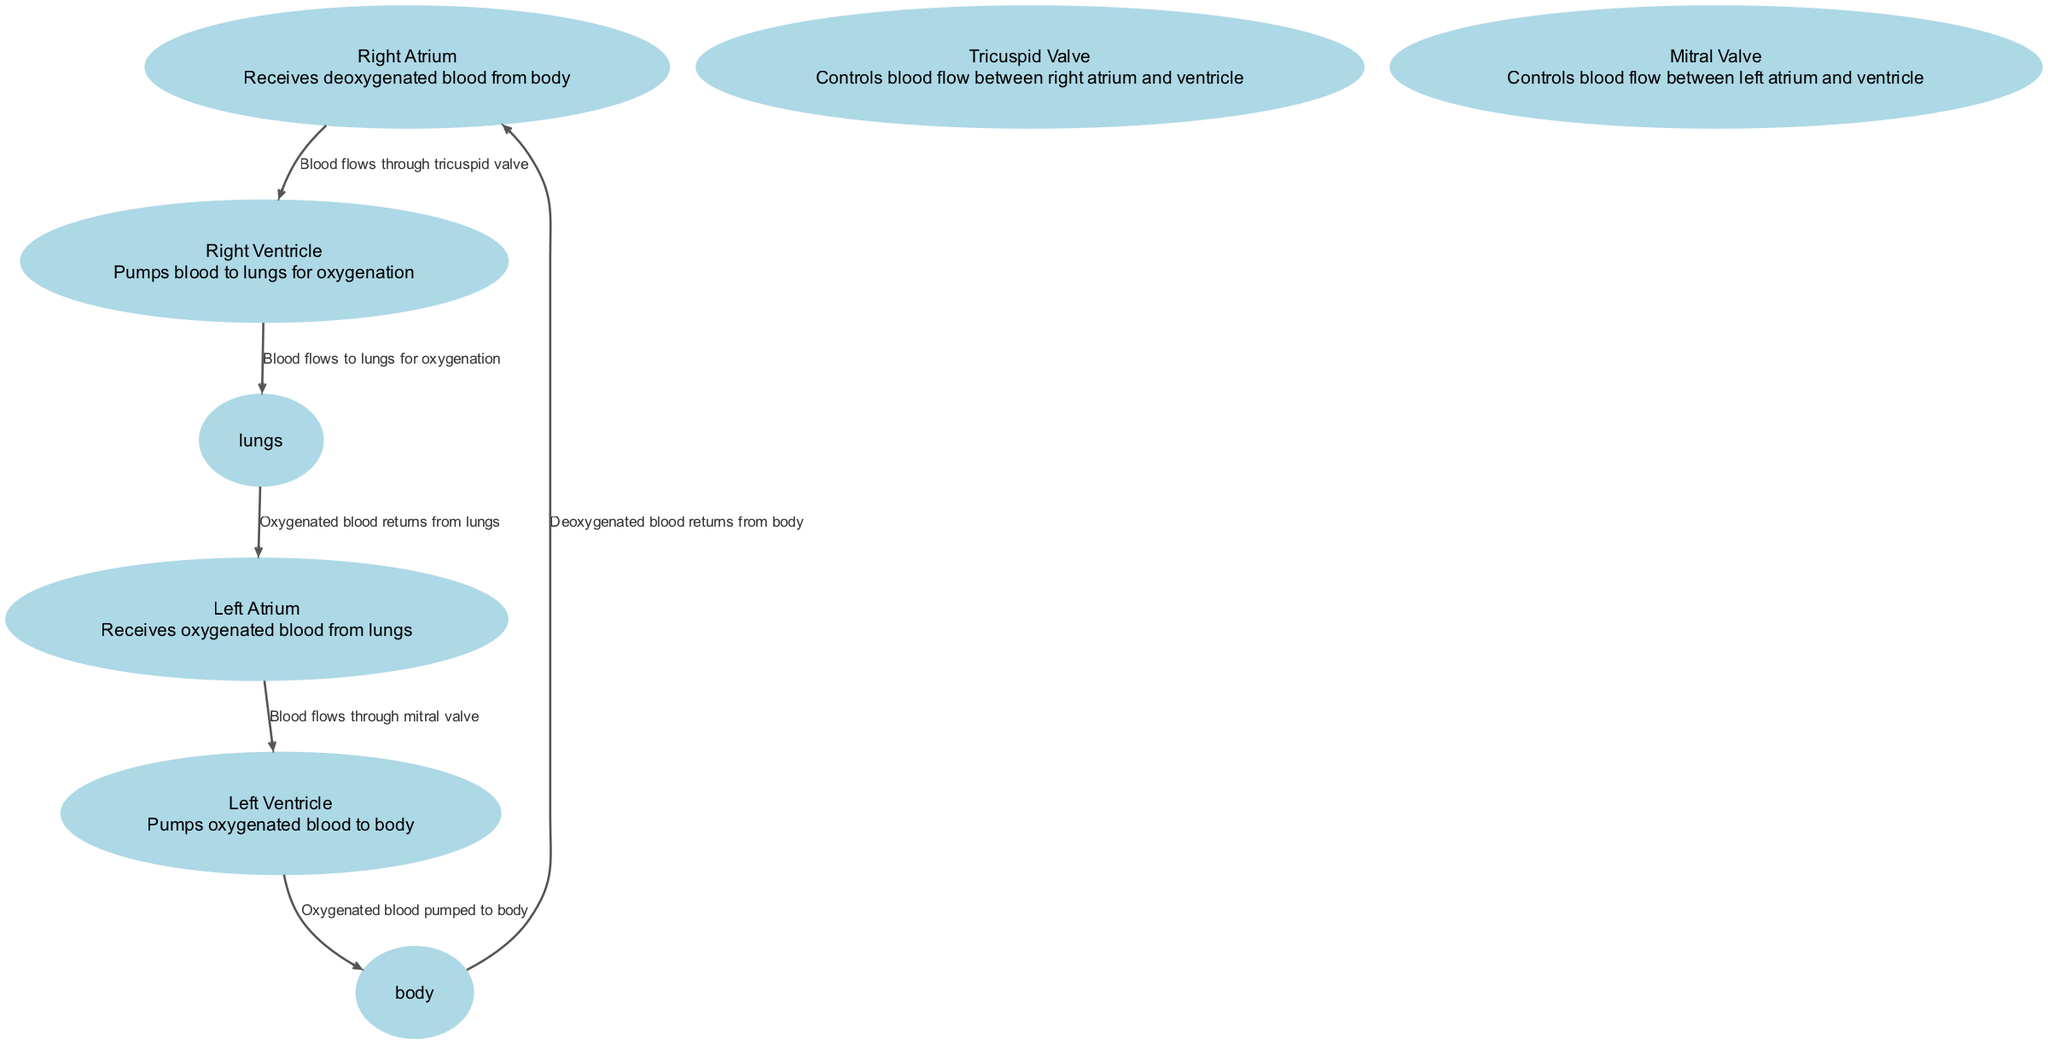What are the four main chambers of the heart? The diagram indicates the four chambers of the heart are the Right Atrium, Left Atrium, Right Ventricle, and Left Ventricle, as these nodes are specifically labeled in the diagram.
Answer: Right Atrium, Left Atrium, Right Ventricle, Left Ventricle Which valve controls blood flow from the right atrium to the right ventricle? The diagram shows an edge labeled "Blood flows through tricuspid valve" connecting the Right Atrium and Right Ventricle, indicating the Tricuspid Valve manages this flow.
Answer: Tricuspid Valve Where does deoxygenated blood return after circulating through the body? In the diagram, there is an edge labeled "Deoxygenated blood returns from body" leading to the Right Atrium, showing that this is the destination for deoxygenated blood.
Answer: Right Atrium How many edges are present in the diagram? By counting the connections listed in the edges data, there are six distinct edges demonstrated in the diagram, representing blood flow direction.
Answer: 6 What is the function of the left ventricle? The Left Ventricle is described as "Pumps oxygenated blood to body" in the node's description on the diagram, indicating its primary function within the heart's operation.
Answer: Pumps oxygenated blood to body Which chamber receives oxygenated blood? The diagram states that the Left Atrium receives oxygenated blood from the lungs, as denoted in its description.
Answer: Left Atrium What is the flow of blood from the right ventricle? The diagram shows an edge labeled "Blood flows to lungs for oxygenation" from the Right Ventricle, indicating that blood is pumped to the lungs for this purpose.
Answer: To lungs for oxygenation What purpose does the mitral valve serve? The description of the Mitral Valve in the diagram indicates it "Controls blood flow between left atrium and ventricle," thus detailing its specific function.
Answer: Controls blood flow between left atrium and ventricle 